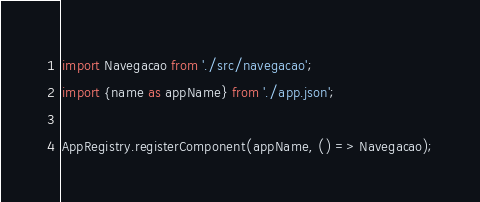Convert code to text. <code><loc_0><loc_0><loc_500><loc_500><_JavaScript_>import Navegacao from './src/navegacao';
import {name as appName} from './app.json';

AppRegistry.registerComponent(appName, () => Navegacao);
</code> 